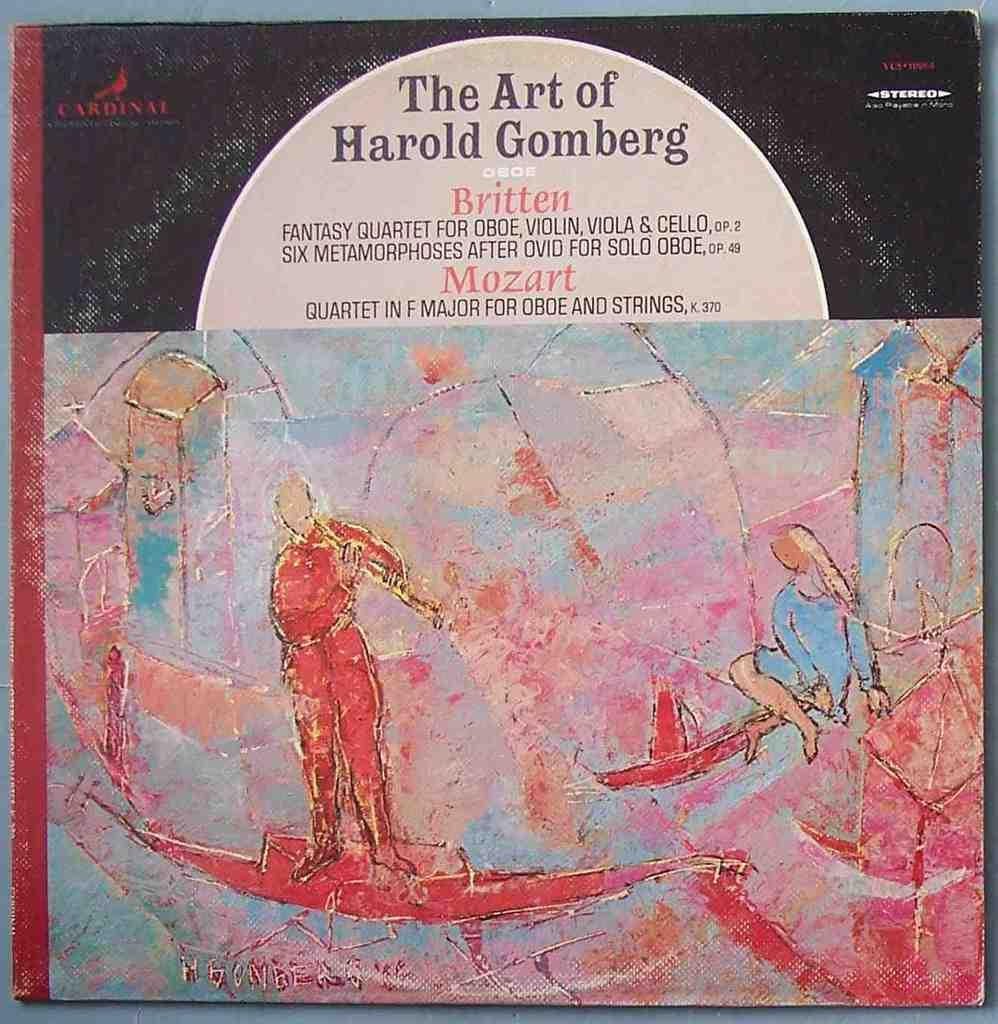<image>
Write a terse but informative summary of the picture. An Album cover of The Art of Harold Gomberg 